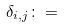Convert formula to latex. <formula><loc_0><loc_0><loc_500><loc_500>\delta _ { i , j } \colon =</formula> 